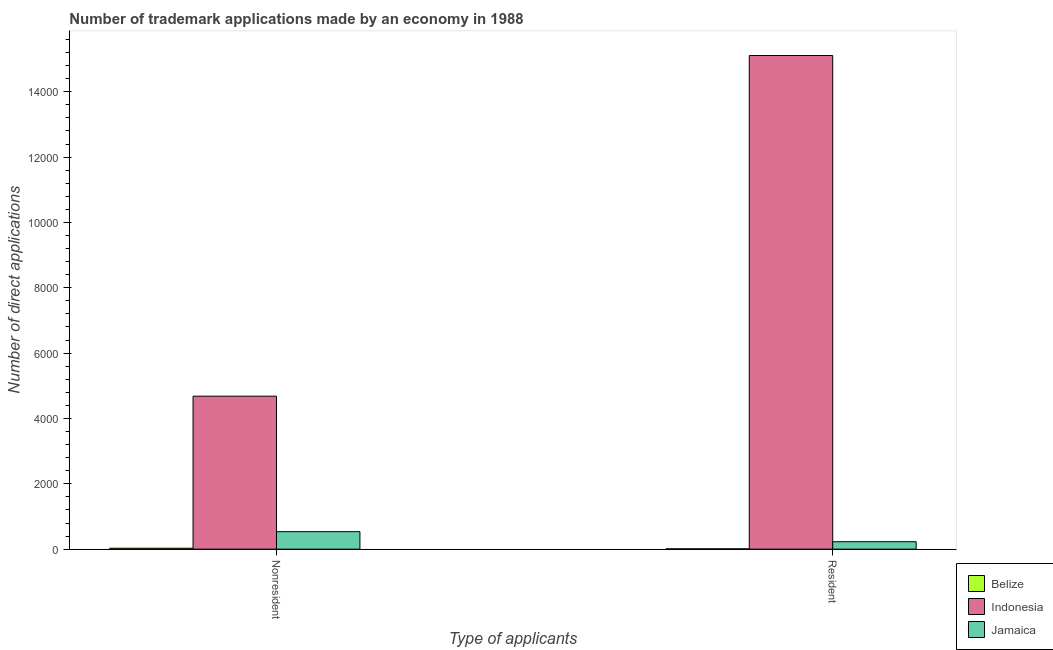How many different coloured bars are there?
Offer a very short reply. 3. Are the number of bars on each tick of the X-axis equal?
Offer a terse response. Yes. How many bars are there on the 1st tick from the right?
Your response must be concise. 3. What is the label of the 1st group of bars from the left?
Provide a short and direct response. Nonresident. What is the number of trademark applications made by non residents in Indonesia?
Your response must be concise. 4682. Across all countries, what is the maximum number of trademark applications made by non residents?
Keep it short and to the point. 4682. Across all countries, what is the minimum number of trademark applications made by residents?
Your response must be concise. 9. In which country was the number of trademark applications made by residents minimum?
Provide a short and direct response. Belize. What is the total number of trademark applications made by residents in the graph?
Your response must be concise. 1.53e+04. What is the difference between the number of trademark applications made by non residents in Belize and that in Indonesia?
Ensure brevity in your answer.  -4654. What is the difference between the number of trademark applications made by non residents in Jamaica and the number of trademark applications made by residents in Belize?
Your answer should be very brief. 526. What is the average number of trademark applications made by residents per country?
Your answer should be compact. 5115. What is the difference between the number of trademark applications made by residents and number of trademark applications made by non residents in Indonesia?
Make the answer very short. 1.04e+04. What is the ratio of the number of trademark applications made by non residents in Indonesia to that in Jamaica?
Your answer should be compact. 8.75. What does the 2nd bar from the left in Resident represents?
Give a very brief answer. Indonesia. What does the 3rd bar from the right in Nonresident represents?
Your response must be concise. Belize. How many bars are there?
Your answer should be compact. 6. Are all the bars in the graph horizontal?
Provide a succinct answer. No. Does the graph contain grids?
Offer a terse response. No. Where does the legend appear in the graph?
Ensure brevity in your answer.  Bottom right. How many legend labels are there?
Give a very brief answer. 3. What is the title of the graph?
Offer a very short reply. Number of trademark applications made by an economy in 1988. Does "Middle East & North Africa (all income levels)" appear as one of the legend labels in the graph?
Your answer should be very brief. No. What is the label or title of the X-axis?
Offer a very short reply. Type of applicants. What is the label or title of the Y-axis?
Your answer should be compact. Number of direct applications. What is the Number of direct applications in Belize in Nonresident?
Offer a very short reply. 28. What is the Number of direct applications in Indonesia in Nonresident?
Your answer should be very brief. 4682. What is the Number of direct applications in Jamaica in Nonresident?
Make the answer very short. 535. What is the Number of direct applications in Belize in Resident?
Offer a terse response. 9. What is the Number of direct applications of Indonesia in Resident?
Make the answer very short. 1.51e+04. What is the Number of direct applications of Jamaica in Resident?
Provide a succinct answer. 227. Across all Type of applicants, what is the maximum Number of direct applications in Belize?
Keep it short and to the point. 28. Across all Type of applicants, what is the maximum Number of direct applications of Indonesia?
Give a very brief answer. 1.51e+04. Across all Type of applicants, what is the maximum Number of direct applications of Jamaica?
Give a very brief answer. 535. Across all Type of applicants, what is the minimum Number of direct applications in Indonesia?
Make the answer very short. 4682. Across all Type of applicants, what is the minimum Number of direct applications in Jamaica?
Offer a terse response. 227. What is the total Number of direct applications of Indonesia in the graph?
Offer a terse response. 1.98e+04. What is the total Number of direct applications in Jamaica in the graph?
Ensure brevity in your answer.  762. What is the difference between the Number of direct applications in Indonesia in Nonresident and that in Resident?
Offer a very short reply. -1.04e+04. What is the difference between the Number of direct applications of Jamaica in Nonresident and that in Resident?
Your response must be concise. 308. What is the difference between the Number of direct applications of Belize in Nonresident and the Number of direct applications of Indonesia in Resident?
Your response must be concise. -1.51e+04. What is the difference between the Number of direct applications of Belize in Nonresident and the Number of direct applications of Jamaica in Resident?
Keep it short and to the point. -199. What is the difference between the Number of direct applications of Indonesia in Nonresident and the Number of direct applications of Jamaica in Resident?
Your answer should be compact. 4455. What is the average Number of direct applications in Indonesia per Type of applicants?
Your response must be concise. 9895.5. What is the average Number of direct applications of Jamaica per Type of applicants?
Give a very brief answer. 381. What is the difference between the Number of direct applications in Belize and Number of direct applications in Indonesia in Nonresident?
Offer a very short reply. -4654. What is the difference between the Number of direct applications in Belize and Number of direct applications in Jamaica in Nonresident?
Your response must be concise. -507. What is the difference between the Number of direct applications in Indonesia and Number of direct applications in Jamaica in Nonresident?
Your answer should be compact. 4147. What is the difference between the Number of direct applications of Belize and Number of direct applications of Indonesia in Resident?
Offer a terse response. -1.51e+04. What is the difference between the Number of direct applications of Belize and Number of direct applications of Jamaica in Resident?
Give a very brief answer. -218. What is the difference between the Number of direct applications in Indonesia and Number of direct applications in Jamaica in Resident?
Make the answer very short. 1.49e+04. What is the ratio of the Number of direct applications of Belize in Nonresident to that in Resident?
Your response must be concise. 3.11. What is the ratio of the Number of direct applications in Indonesia in Nonresident to that in Resident?
Offer a very short reply. 0.31. What is the ratio of the Number of direct applications of Jamaica in Nonresident to that in Resident?
Make the answer very short. 2.36. What is the difference between the highest and the second highest Number of direct applications in Belize?
Provide a short and direct response. 19. What is the difference between the highest and the second highest Number of direct applications in Indonesia?
Your response must be concise. 1.04e+04. What is the difference between the highest and the second highest Number of direct applications in Jamaica?
Offer a very short reply. 308. What is the difference between the highest and the lowest Number of direct applications in Indonesia?
Your response must be concise. 1.04e+04. What is the difference between the highest and the lowest Number of direct applications of Jamaica?
Your response must be concise. 308. 